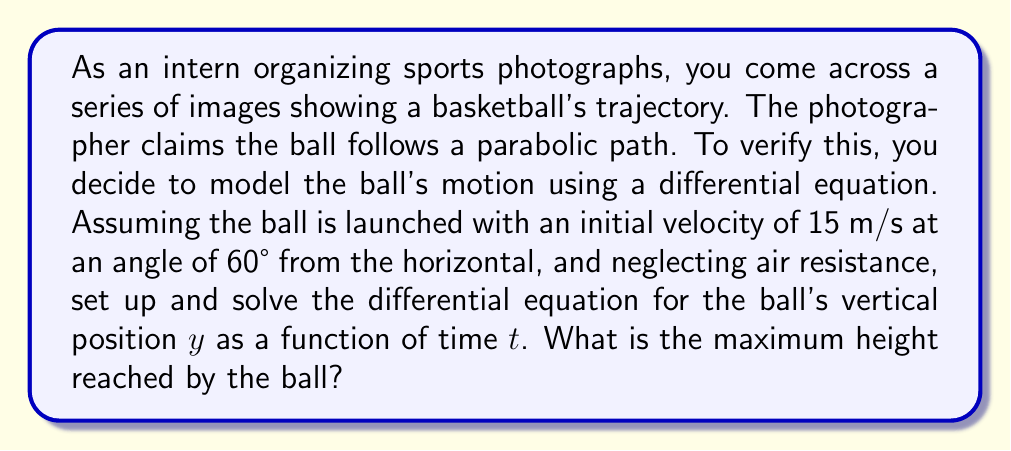Can you solve this math problem? Let's approach this step-by-step:

1) First, we need to set up our differential equation. The vertical motion of the ball is governed by gravity, which gives us the second-order differential equation:

   $$\frac{d^2y}{dt^2} = -g$$

   where $g$ is the acceleration due to gravity (approximately 9.8 m/s²).

2) We need two initial conditions to solve this equation:
   - Initial vertical velocity: $v_y(0) = 15 \sin(60°) = 15 \cdot \frac{\sqrt{3}}{2} \approx 12.99$ m/s
   - Initial height: $y(0) = 0$ m

3) Integrating the differential equation once:

   $$\frac{dy}{dt} = -gt + C_1$$

4) Using the initial velocity condition:

   $$12.99 = C_1$$

5) Integrating again:

   $$y = -\frac{1}{2}gt^2 + 12.99t + C_2$$

6) Using the initial height condition:

   $$0 = 0 + 0 + C_2$$
   
   So, $C_2 = 0$

7) Therefore, the equation for the ball's height as a function of time is:

   $$y = -4.9t^2 + 12.99t$$

8) To find the maximum height, we need to find when the vertical velocity is zero:

   $$\frac{dy}{dt} = -9.8t + 12.99 = 0$$
   $$t = \frac{12.99}{9.8} \approx 1.33 \text{ seconds}$$

9) Plugging this time back into our height equation:

   $$y_{\text{max}} = -4.9(1.33)^2 + 12.99(1.33) \approx 8.6 \text{ meters}$$
Answer: The maximum height reached by the basketball is approximately 8.6 meters. 